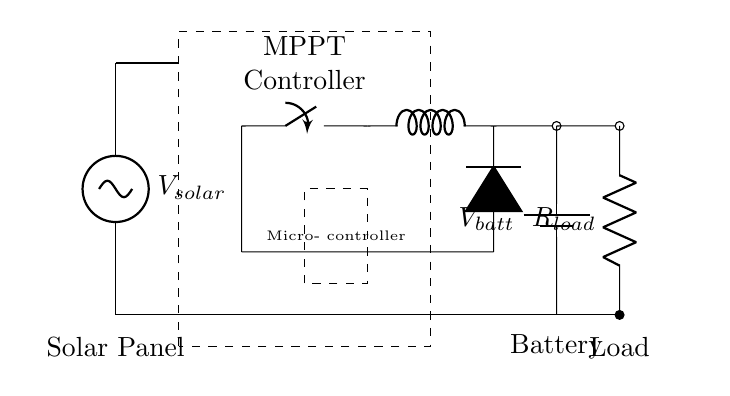What component is represented by the dashed rectangle? The dashed rectangle encloses the MPPT controller, which is positioned between the solar panel and the buck converter. The label indicates its function within the circuit.
Answer: MPPT Controller What is the role of the buck converter in this circuit? The buck converter is used to step down the voltage from the MPPT controller to a level suitable for charging the battery or powering the load. It regulates the voltage while maintaining efficiency.
Answer: Step-down voltage What are the two main energy sources in this circuit? The two main sources of energy in this circuit are the solar panel and the battery. The solar panel generates power, while the battery stores energy for later use to supply the load.
Answer: Solar Panel, Battery What is the function of the microcontroller? The microcontroller controls the operation of the MPPT controller and manages the charging of the battery, as well as monitoring the performance of the entire circuit. Its role is crucial for efficient energy use.
Answer: Control circuit How is the load connected to the circuit? The load is connected in series with the battery and the buck converter. The load receives power delivered from the battery that has been regulated by the circuit components for optimal performance.
Answer: In series What is the voltage of the solar panel? The voltage of the solar panel is represented by V_solar, indicating that the exact value depends on the specific solar panel used but is the potential generated by it.
Answer: V_solar What component restricts current flow to the load? The component that restricts current flow to the load is the resistor, labeled R_load. It can dictate how much current is allowed to flow to the load based on its resistance.
Answer: Resistor 